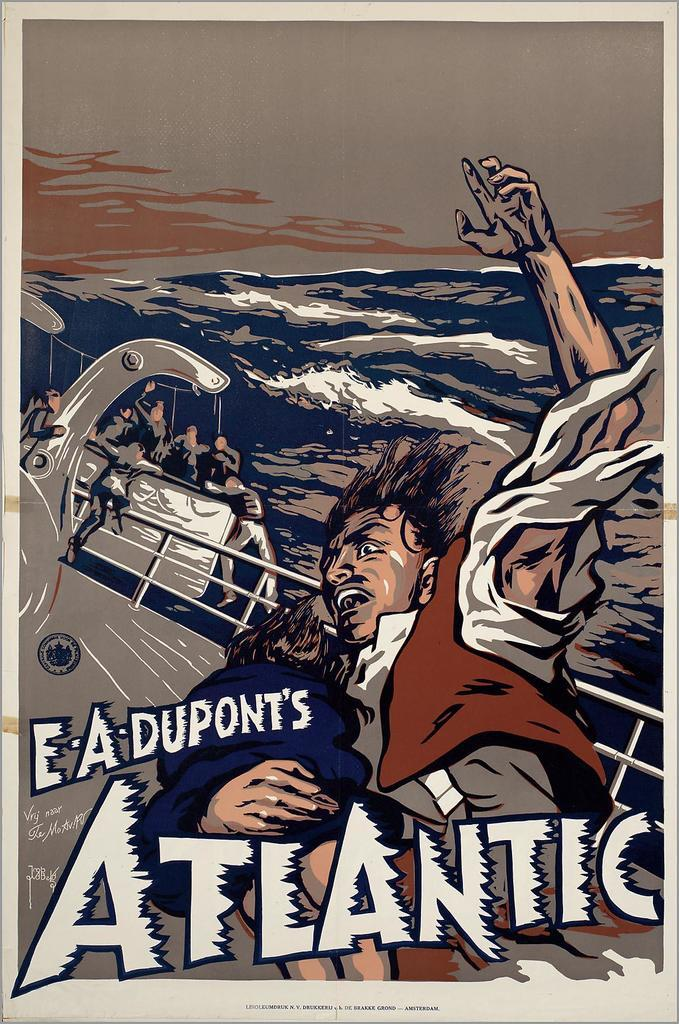<image>
Provide a brief description of the given image. a man falling on a boat with the word Atlantic on it 